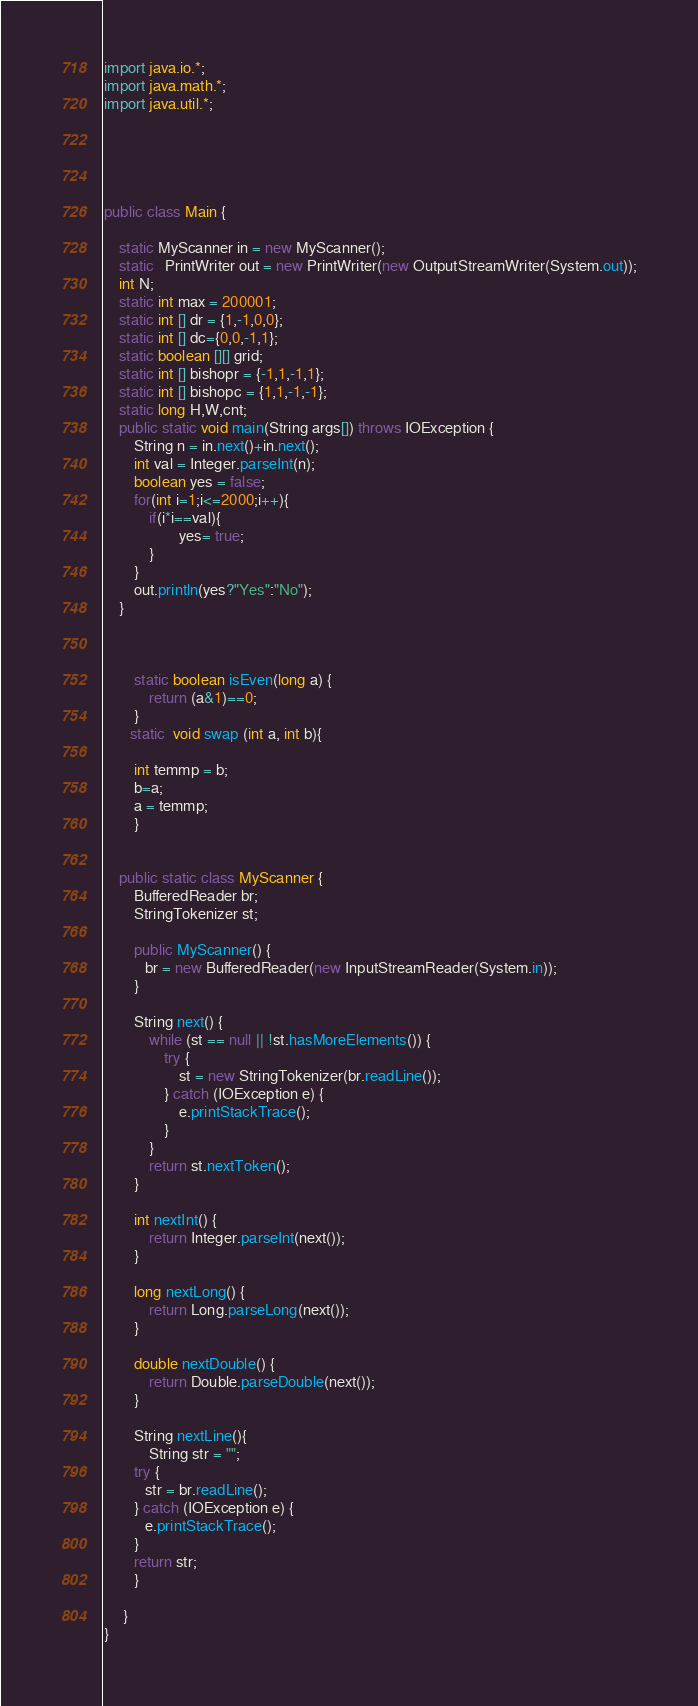<code> <loc_0><loc_0><loc_500><loc_500><_Java_>import java.io.*;
import java.math.*;
import java.util.*;





public class Main {

    static MyScanner in = new MyScanner();
    static   PrintWriter out = new PrintWriter(new OutputStreamWriter(System.out));
    int N;
    static int max = 200001;
    static int [] dr = {1,-1,0,0};
    static int [] dc={0,0,-1,1};
    static boolean [][] grid;
    static int [] bishopr = {-1,1,-1,1};
    static int [] bishopc = {1,1,-1,-1};
    static long H,W,cnt;
    public static void main(String args[]) throws IOException {
        String n = in.next()+in.next();
        int val = Integer.parseInt(n);
        boolean yes = false;
        for(int i=1;i<=2000;i++){
            if(i*i==val){
                    yes= true;
            }
        }
        out.println(yes?"Yes":"No");
    }



        static boolean isEven(long a) {
            return (a&1)==0;
        }
       static  void swap (int a, int b){

        int temmp = b;
        b=a;
        a = temmp;
        }
    

    public static class MyScanner {
        BufferedReader br;
        StringTokenizer st;
   
        public MyScanner() {
           br = new BufferedReader(new InputStreamReader(System.in));
        }
   
        String next() {
            while (st == null || !st.hasMoreElements()) {
                try {
                    st = new StringTokenizer(br.readLine());
                } catch (IOException e) {
                    e.printStackTrace();
                }
            }
            return st.nextToken();
        }
   
        int nextInt() {
            return Integer.parseInt(next());
        }
   
        long nextLong() {
            return Long.parseLong(next());
        }
   
        double nextDouble() {
            return Double.parseDouble(next());
        }
   
        String nextLine(){
            String str = "";
        try {
           str = br.readLine();
        } catch (IOException e) {
           e.printStackTrace();
        }
        return str;
        }
  
     }
}</code> 